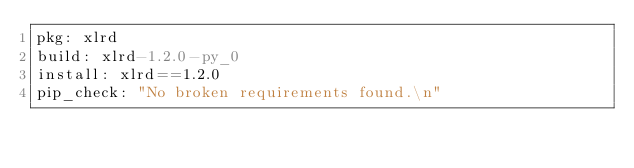<code> <loc_0><loc_0><loc_500><loc_500><_YAML_>pkg: xlrd
build: xlrd-1.2.0-py_0
install: xlrd==1.2.0
pip_check: "No broken requirements found.\n"
</code> 